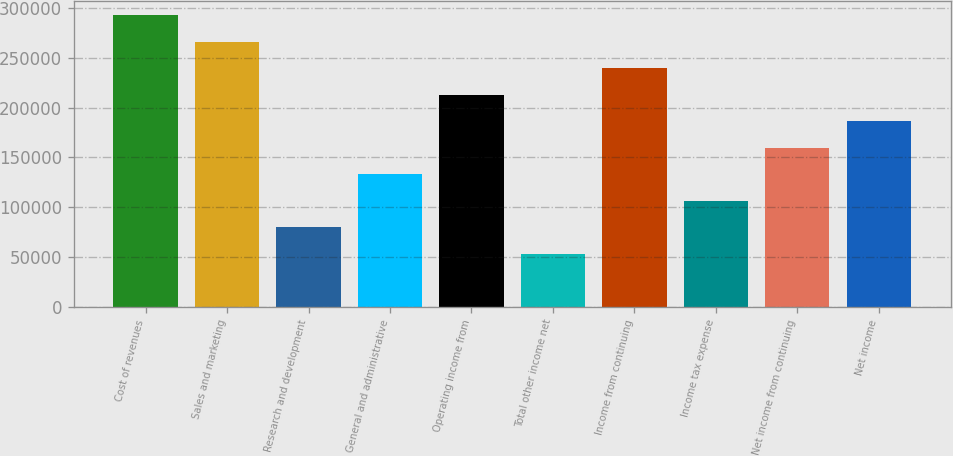<chart> <loc_0><loc_0><loc_500><loc_500><bar_chart><fcel>Cost of revenues<fcel>Sales and marketing<fcel>Research and development<fcel>General and administrative<fcel>Operating income from<fcel>Total other income net<fcel>Income from continuing<fcel>Income tax expense<fcel>Net income from continuing<fcel>Net income<nl><fcel>292687<fcel>266079<fcel>79823.7<fcel>133040<fcel>212863<fcel>53215.8<fcel>239471<fcel>106432<fcel>159647<fcel>186255<nl></chart> 